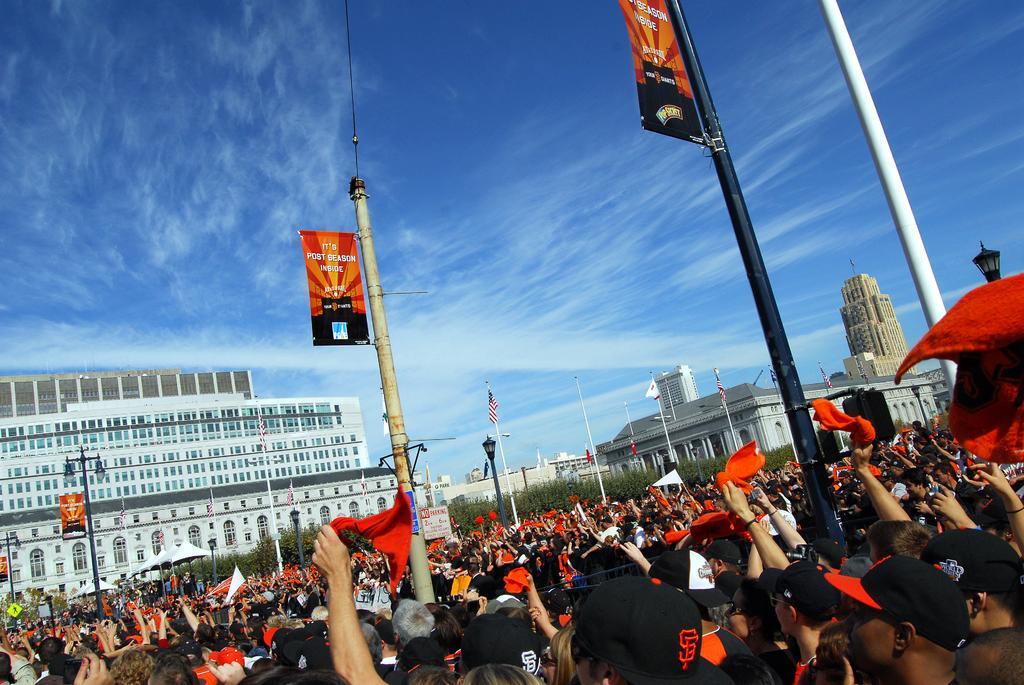In one or two sentences, can you explain what this image depicts? At the bottom of this image, there are persons, poles, trees and buildings on the ground. In the background, there are clouds in the blue sky. 